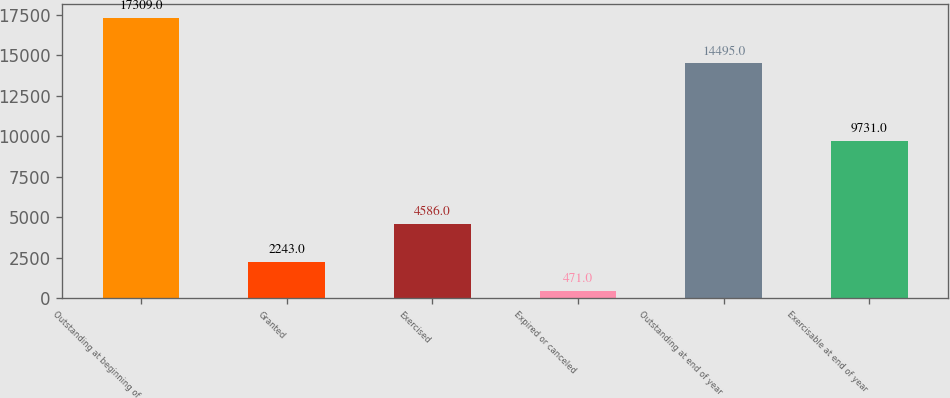<chart> <loc_0><loc_0><loc_500><loc_500><bar_chart><fcel>Outstanding at beginning of<fcel>Granted<fcel>Exercised<fcel>Expired or canceled<fcel>Outstanding at end of year<fcel>Exercisable at end of year<nl><fcel>17309<fcel>2243<fcel>4586<fcel>471<fcel>14495<fcel>9731<nl></chart> 